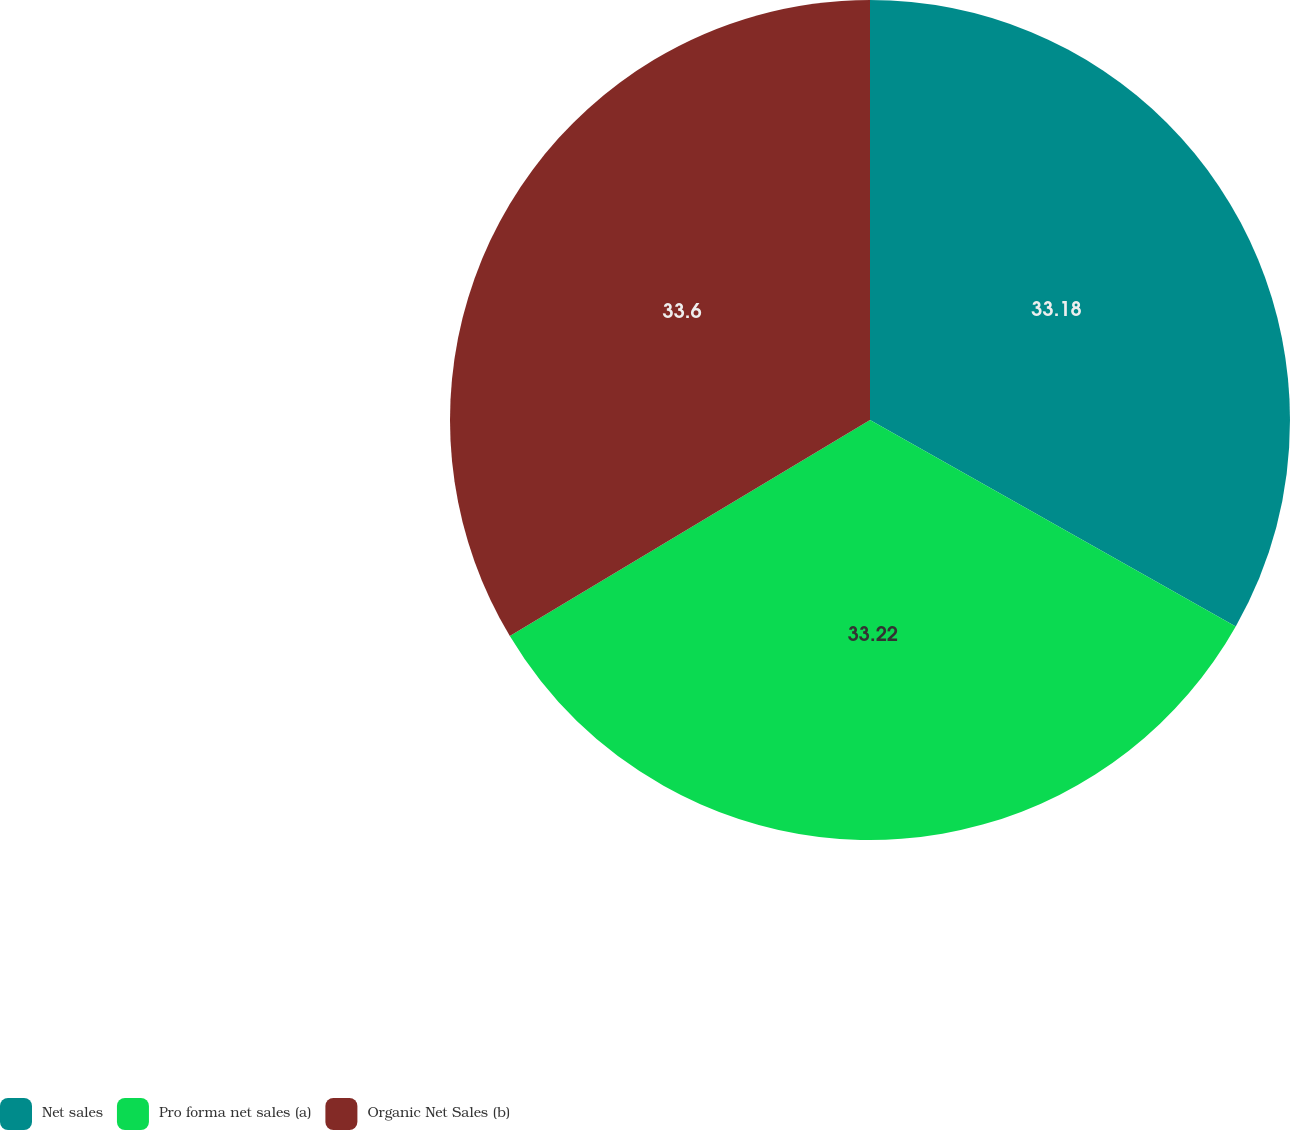Convert chart to OTSL. <chart><loc_0><loc_0><loc_500><loc_500><pie_chart><fcel>Net sales<fcel>Pro forma net sales (a)<fcel>Organic Net Sales (b)<nl><fcel>33.18%<fcel>33.22%<fcel>33.6%<nl></chart> 